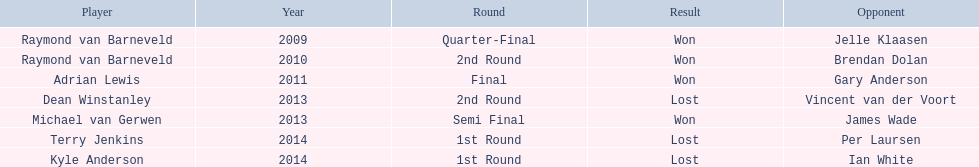What athletes participated in the pdc world darts championship? Raymond van Barneveld, Raymond van Barneveld, Adrian Lewis, Dean Winstanley, Michael van Gerwen, Terry Jenkins, Kyle Anderson. From these athletes, who was unsuccessful? Dean Winstanley, Terry Jenkins, Kyle Anderson. Which among them suffered a loss in 2014? Terry Jenkins, Kyle Anderson. What are the athletes besides kyle anderson? Terry Jenkins. 